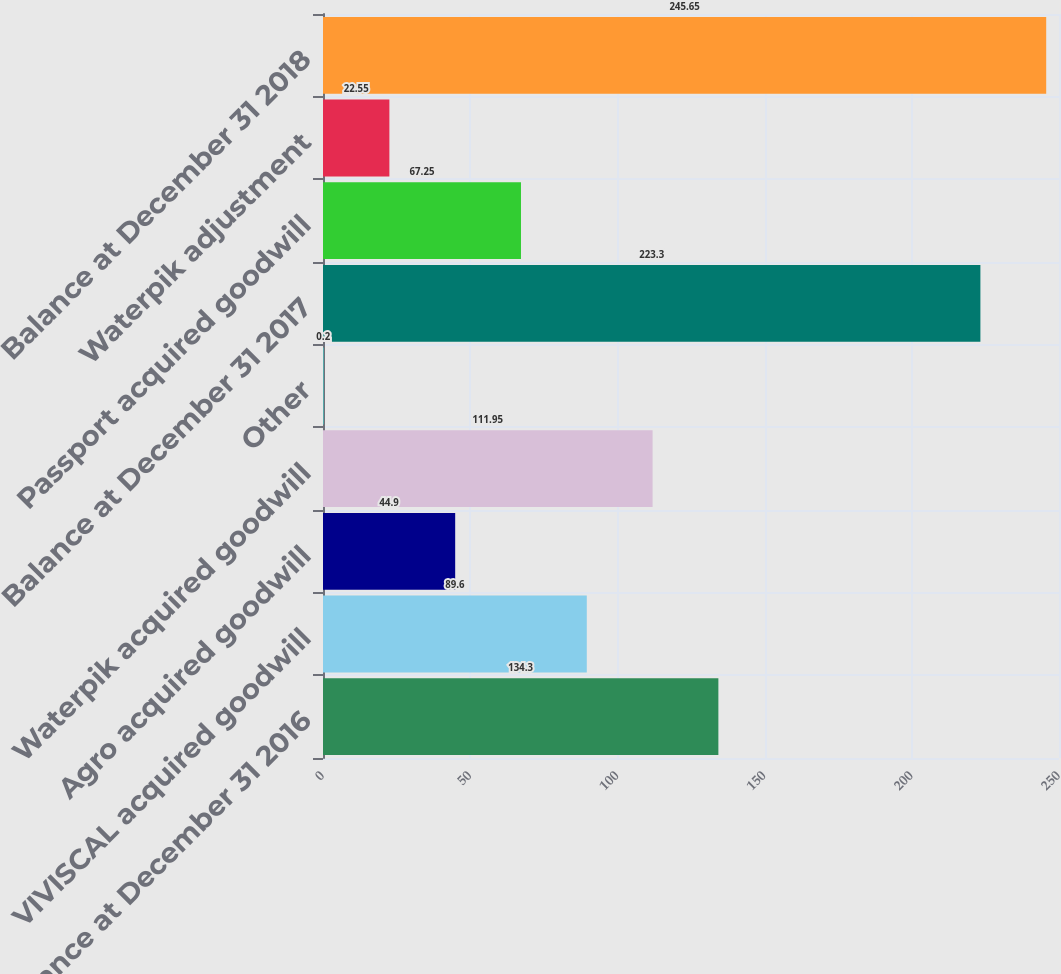Convert chart. <chart><loc_0><loc_0><loc_500><loc_500><bar_chart><fcel>Balance at December 31 2016<fcel>VIVISCAL acquired goodwill<fcel>Agro acquired goodwill<fcel>Waterpik acquired goodwill<fcel>Other<fcel>Balance at December 31 2017<fcel>Passport acquired goodwill<fcel>Waterpik adjustment<fcel>Balance at December 31 2018<nl><fcel>134.3<fcel>89.6<fcel>44.9<fcel>111.95<fcel>0.2<fcel>223.3<fcel>67.25<fcel>22.55<fcel>245.65<nl></chart> 